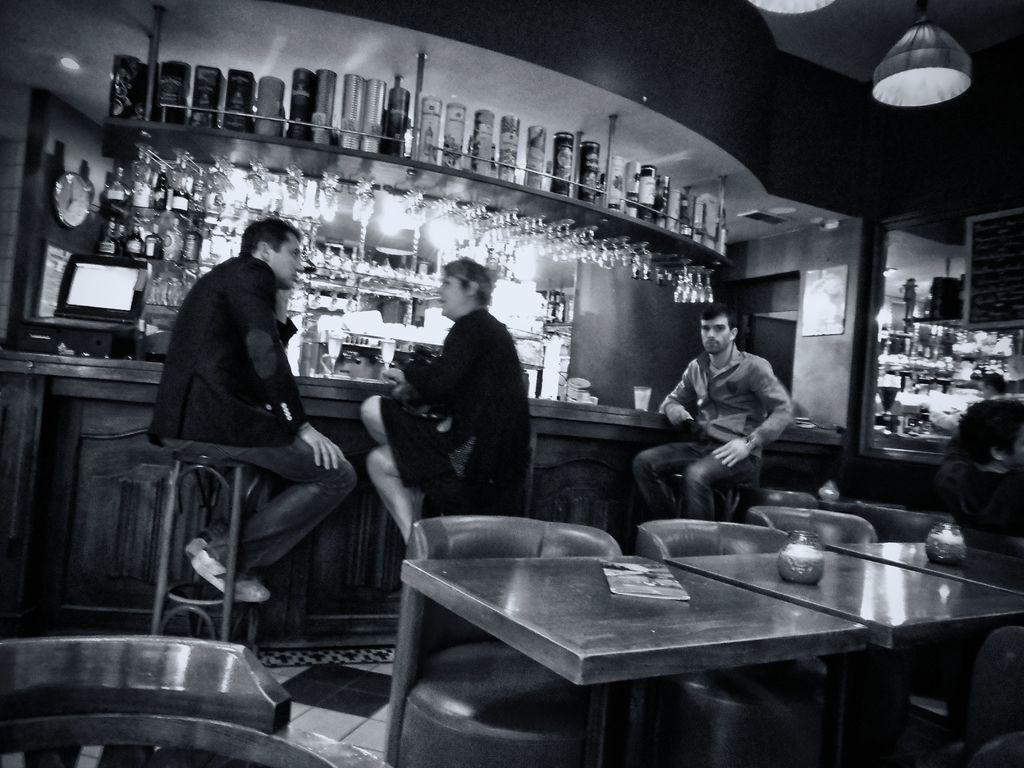In one or two sentences, can you explain what this image depicts? In this image i can see two men and a woman sitting, there is a table and a chair at the background there are few bottles in a cupboard, a desk top and a clock. 